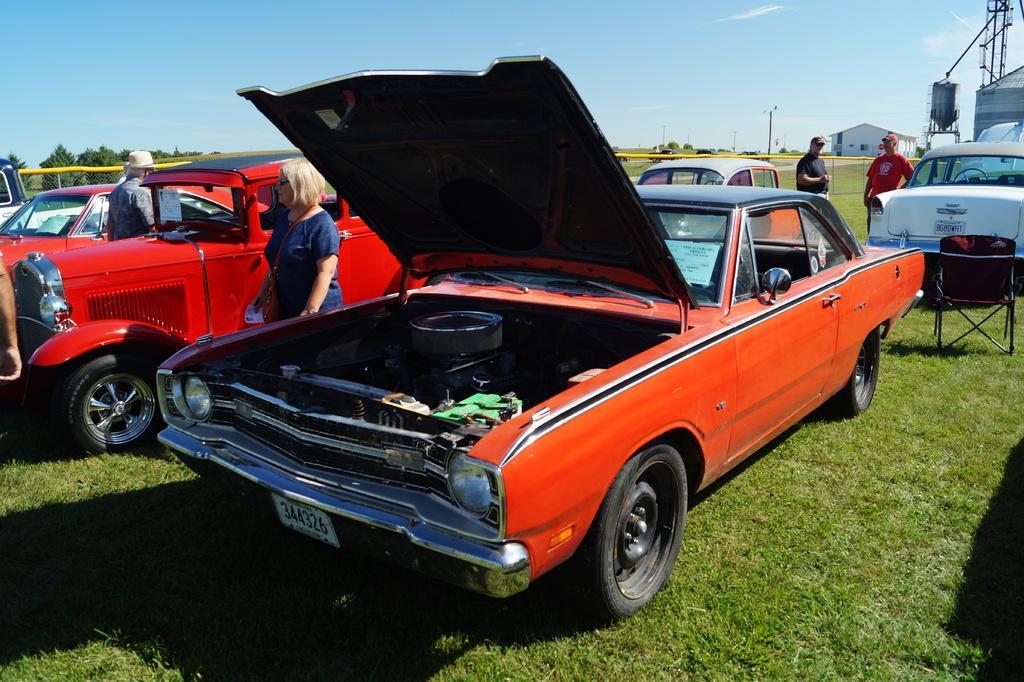Could you give a brief overview of what you see in this image? In this image there are cars and we can see people. In the background there are trees and sky. We can see poles and there is a shed. At the bottom there is grass. 